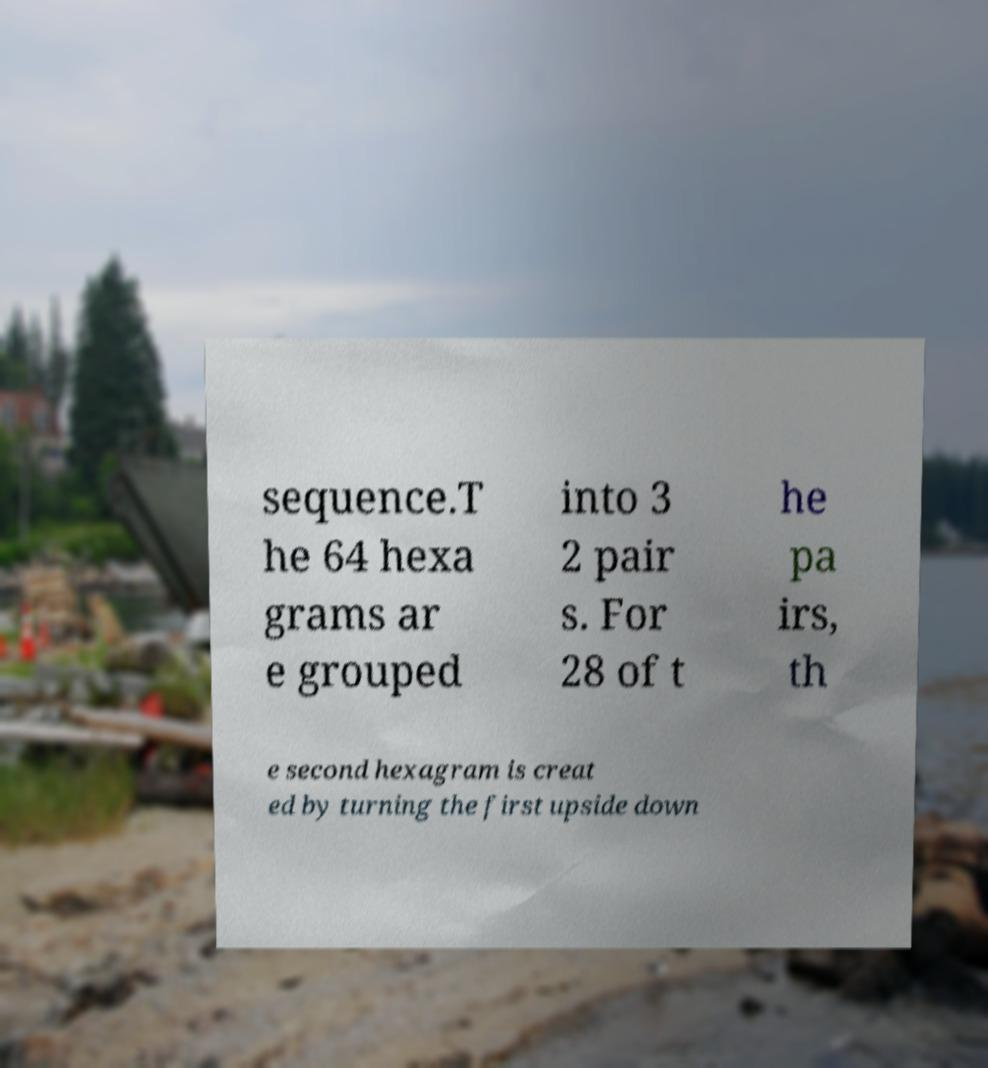Please identify and transcribe the text found in this image. sequence.T he 64 hexa grams ar e grouped into 3 2 pair s. For 28 of t he pa irs, th e second hexagram is creat ed by turning the first upside down 